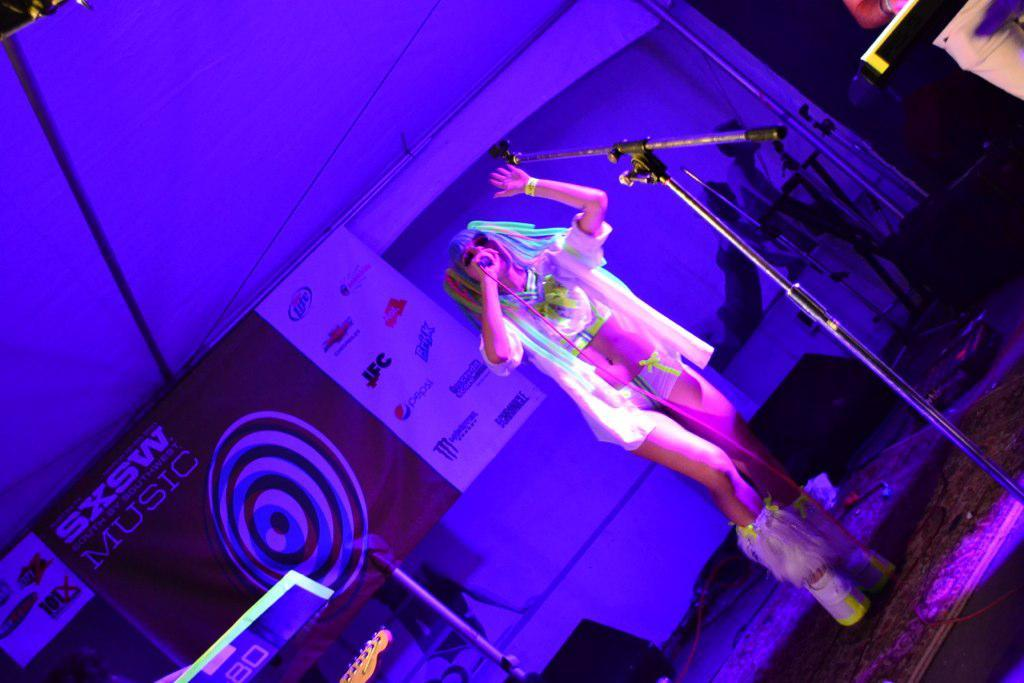Who is the main subject in the image? There is a woman in the image. Where is the woman located? The woman is standing on a stage. What is the woman doing in the image? The woman is singing. What can be seen in the background of the image? There is a banner in the image. What is depicted on the banner? The banner has music instruments depicted on it. What is the appearance of the banner? The banner has a purple light reflection. What type of wrench is being used by the woman in the image? There is no wrench present in the image; the woman is singing on a stage. What tin object can be seen in the image? There is no tin object present in the image. 